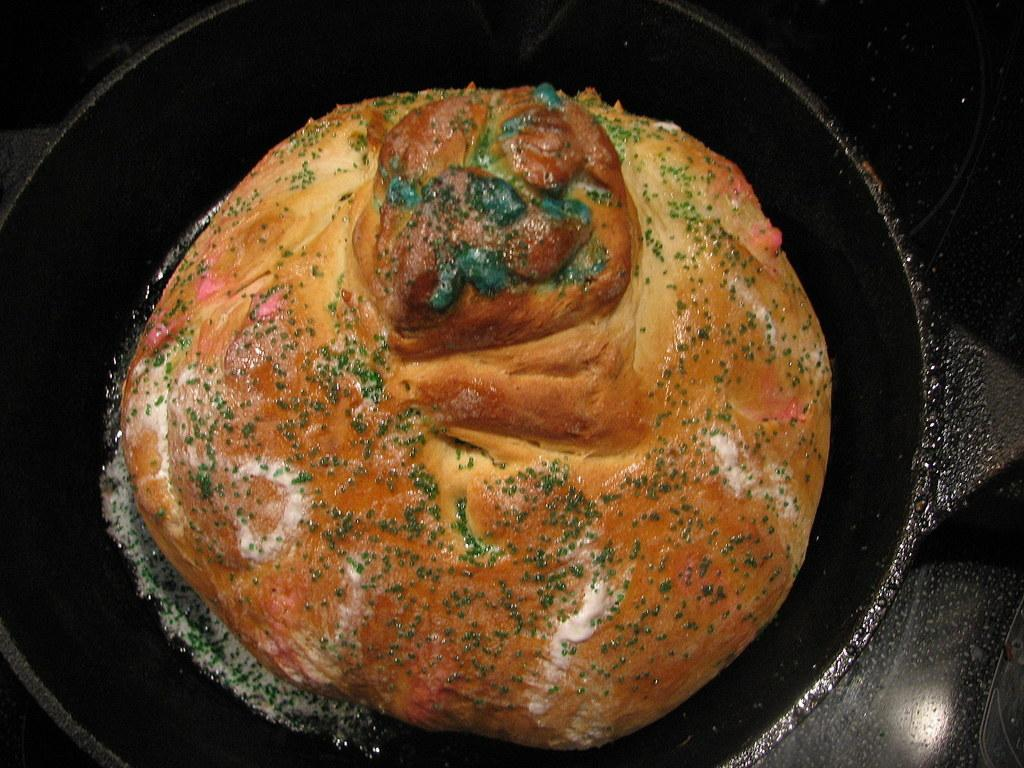What is on the black pan in the image? There is food on a black pan in the image. What color is the surface that the pan is on? There is a black surface visible in the image. Is there a bridge visible in the image? No, there is no bridge present in the image. What type of house can be seen in the background of the image? There is no house visible in the image; it only shows a black pan with food and a black surface. 